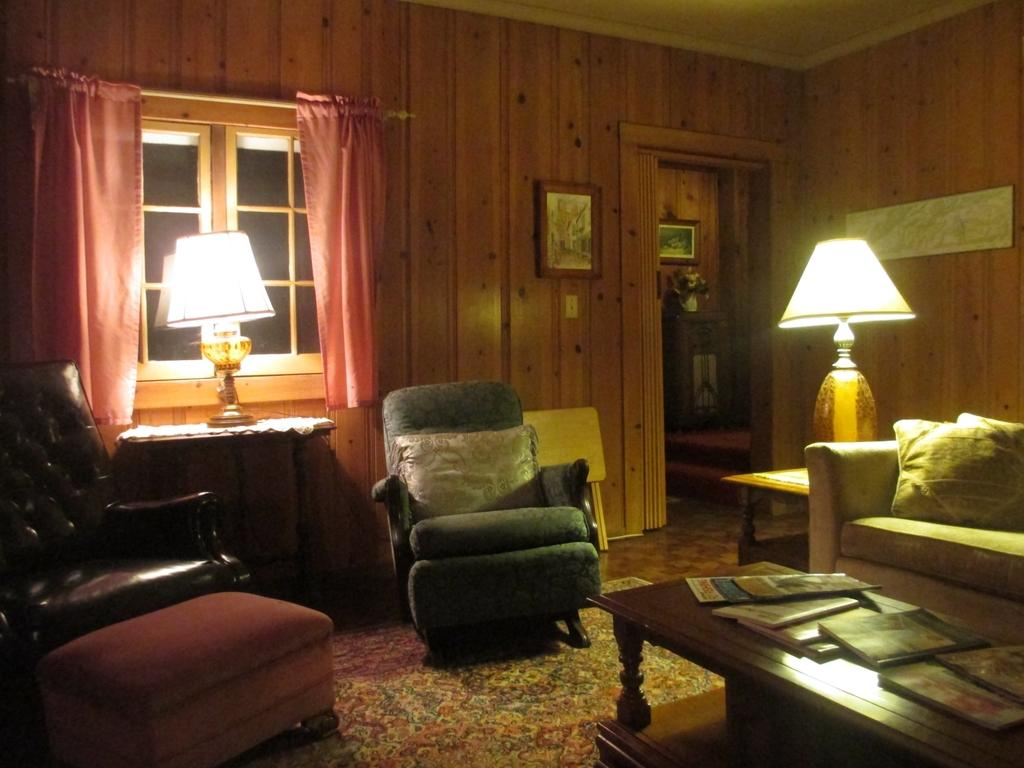How many chairs are in the living room? There are two chairs in the living room. What type of furniture is present for lighting purposes? There are two lamps in the living room. What type of seating is available for multiple people? There is a sofa in the living room. What type of surface is available for placing objects? There is a table in the living room. Where is the jewel placed on the table in the living room? There is no mention of a jewel in the provided facts, so we cannot determine its location on the table. 